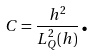Convert formula to latex. <formula><loc_0><loc_0><loc_500><loc_500>C = \frac { h ^ { 2 } } { L _ { Q } ^ { 2 } ( h ) } \text {.}</formula> 